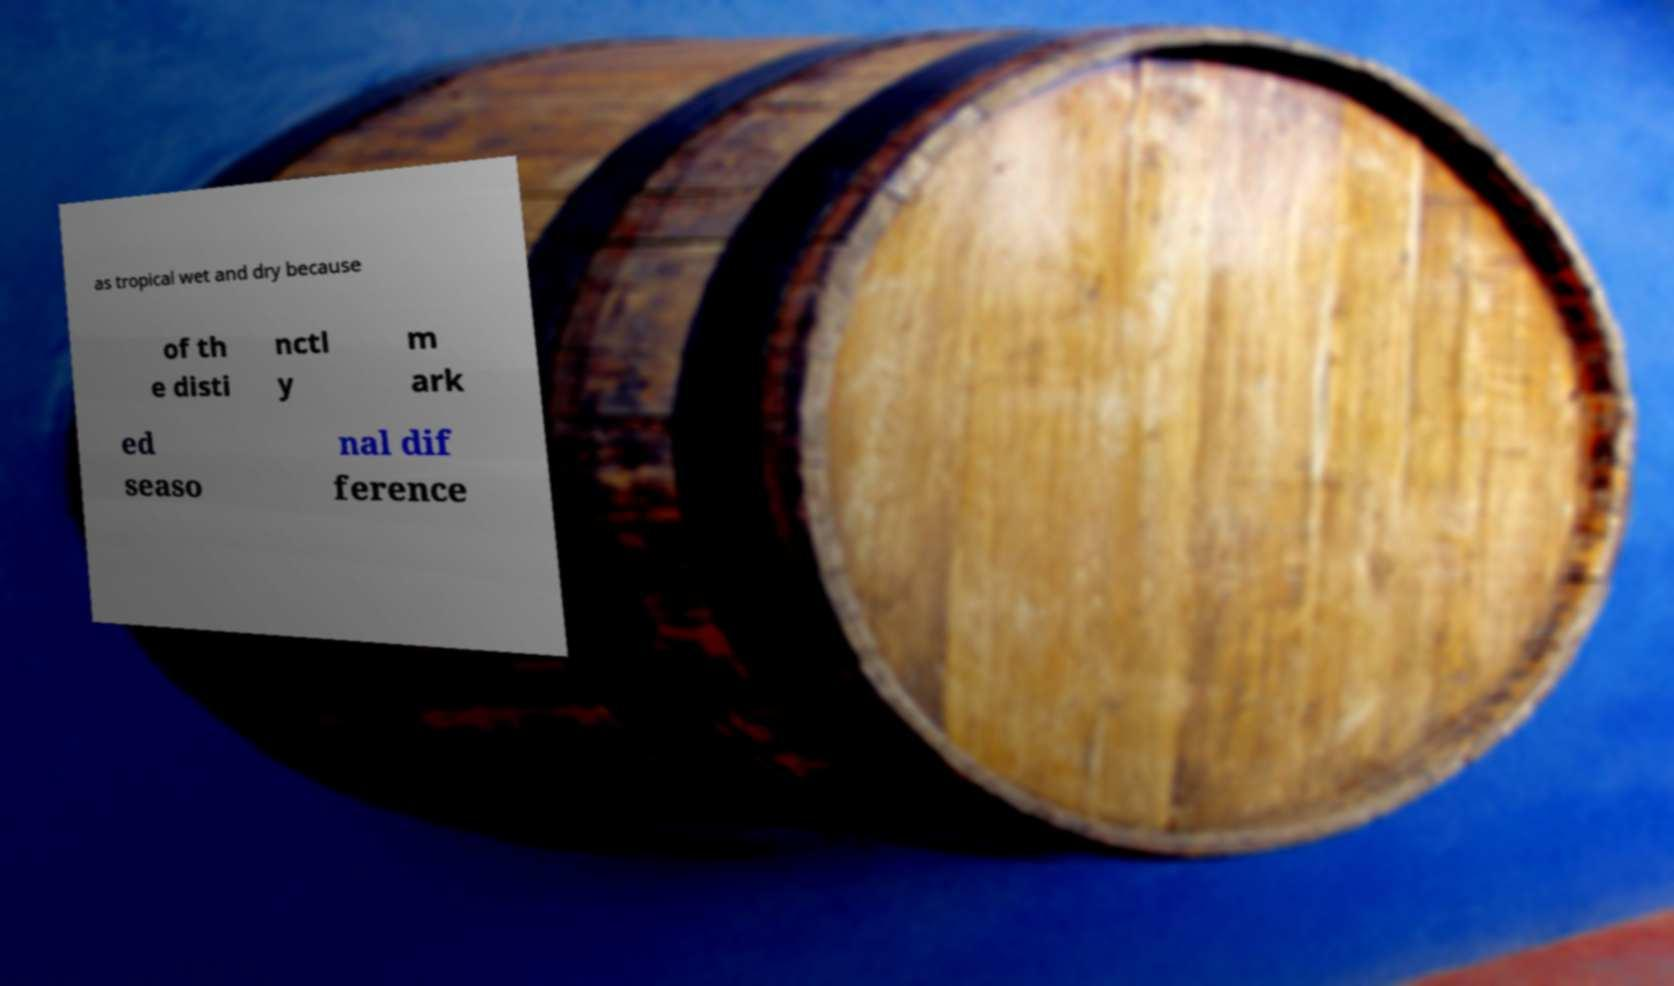There's text embedded in this image that I need extracted. Can you transcribe it verbatim? as tropical wet and dry because of th e disti nctl y m ark ed seaso nal dif ference 